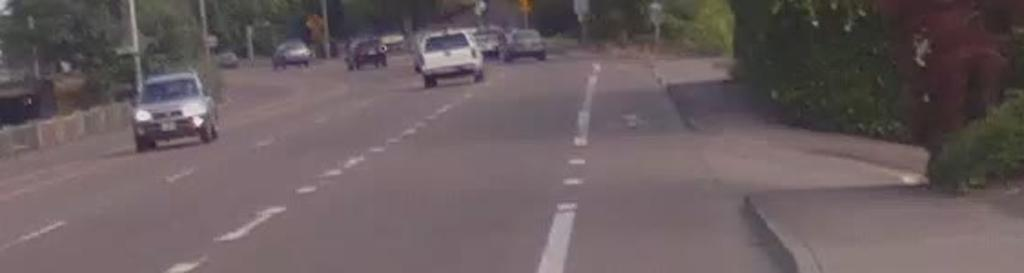What type of pathway is visible in the image? There is a road in the image. What is happening on the road? Vehicles are present on the road. What structures can be seen alongside the road? There are poles visible in the image. What type of vegetation is present in the image? Trees are present in the image. What type of riddle can be seen on the side of the road in the image? There is no riddle present on the side of the road in the image. What is the weight of the feather that is resting on the vehicle in the image? There is no feather present on any vehicle in the image. 